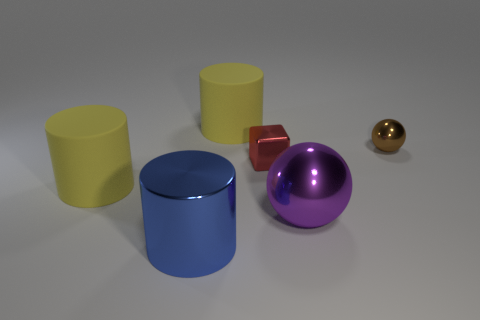Does the large shiny thing that is on the right side of the large shiny cylinder have the same color as the metal block?
Offer a terse response. No. What shape is the big object to the right of the yellow matte thing right of the metal cylinder?
Make the answer very short. Sphere. Are there any blue rubber blocks that have the same size as the purple metallic object?
Your answer should be very brief. No. Is the number of small green rubber cylinders less than the number of metallic blocks?
Ensure brevity in your answer.  Yes. There is a yellow matte object in front of the large yellow matte thing that is behind the small thing that is left of the big purple metal object; what is its shape?
Offer a terse response. Cylinder. What number of things are rubber objects in front of the small brown metallic ball or large things behind the red object?
Provide a succinct answer. 2. Are there any big matte objects in front of the blue metallic object?
Offer a very short reply. No. How many objects are yellow matte things that are on the left side of the tiny red metal block or large red rubber balls?
Offer a terse response. 2. How many purple things are large objects or big metal cylinders?
Make the answer very short. 1. Is the number of big blue objects that are in front of the blue cylinder less than the number of red metal cubes?
Make the answer very short. Yes. 